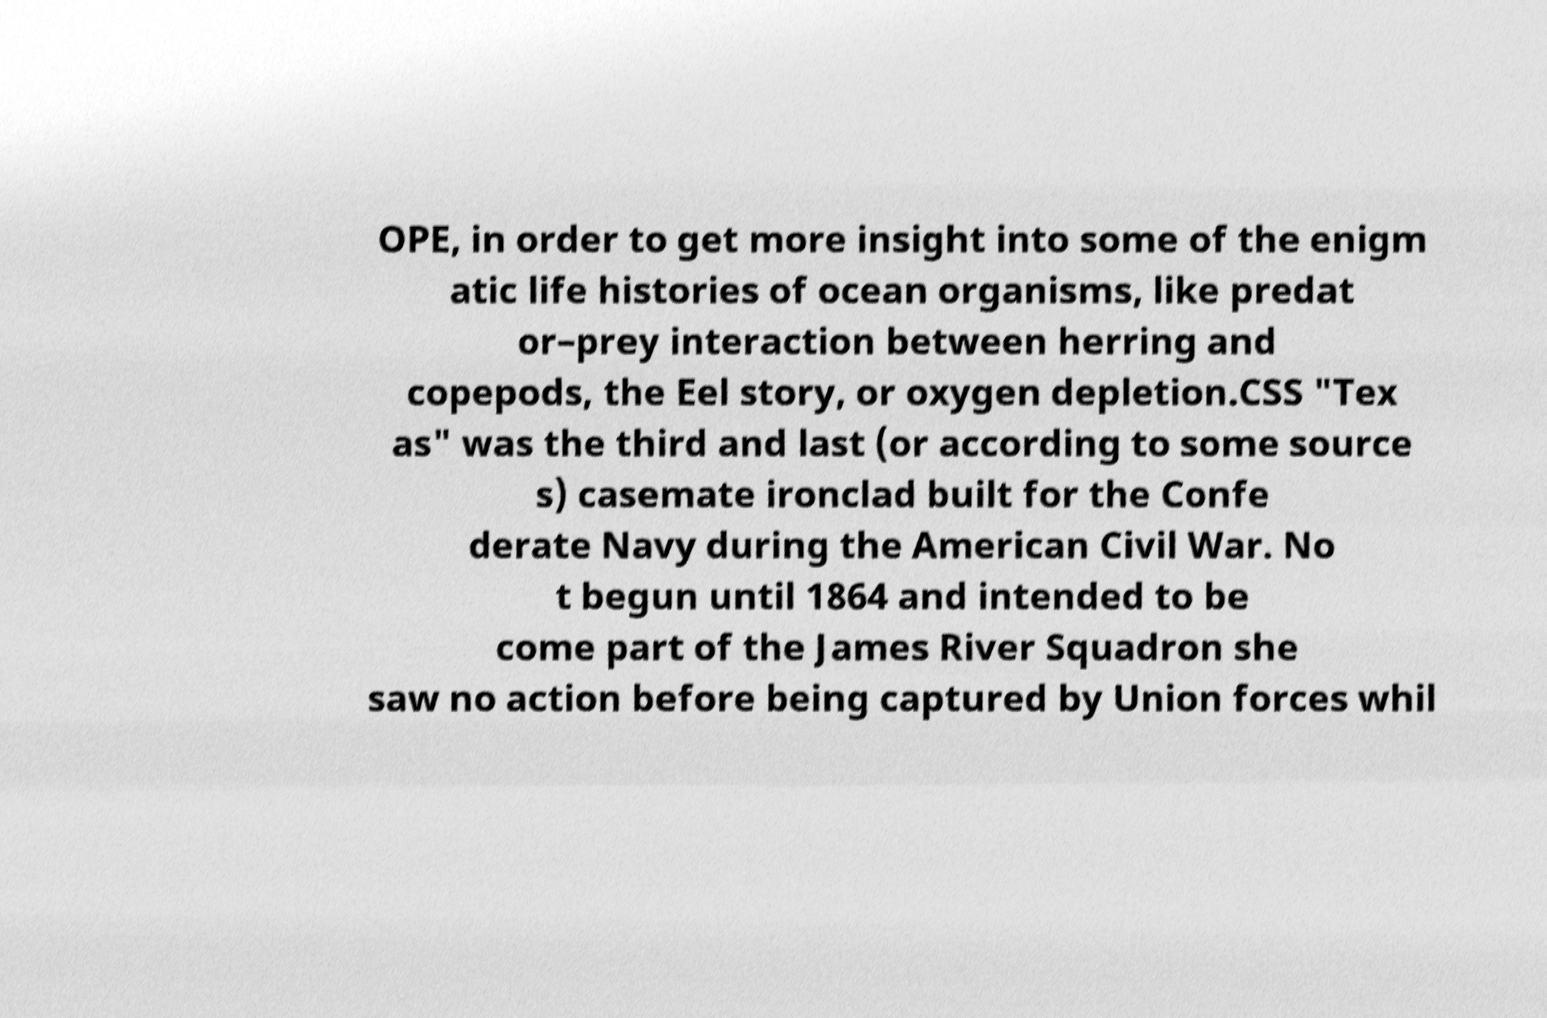For documentation purposes, I need the text within this image transcribed. Could you provide that? OPE, in order to get more insight into some of the enigm atic life histories of ocean organisms, like predat or–prey interaction between herring and copepods, the Eel story, or oxygen depletion.CSS "Tex as" was the third and last (or according to some source s) casemate ironclad built for the Confe derate Navy during the American Civil War. No t begun until 1864 and intended to be come part of the James River Squadron she saw no action before being captured by Union forces whil 